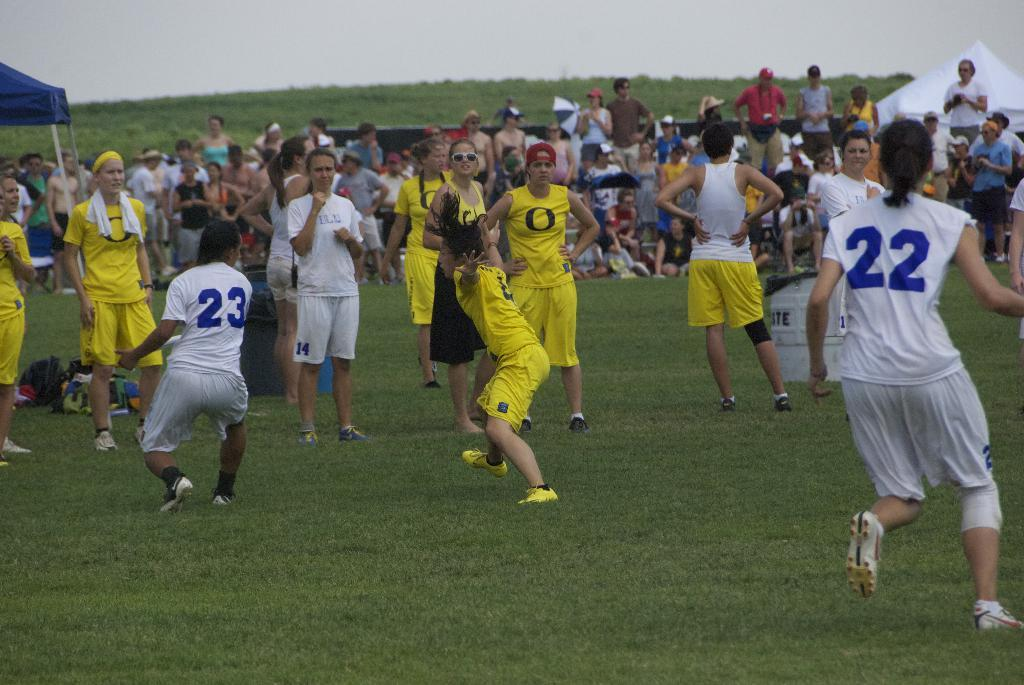<image>
Create a compact narrative representing the image presented. Several players, including jersey numbers 23 and 22, are on a field. 